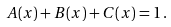Convert formula to latex. <formula><loc_0><loc_0><loc_500><loc_500>A ( x ) + B ( x ) + C ( x ) = 1 \, .</formula> 